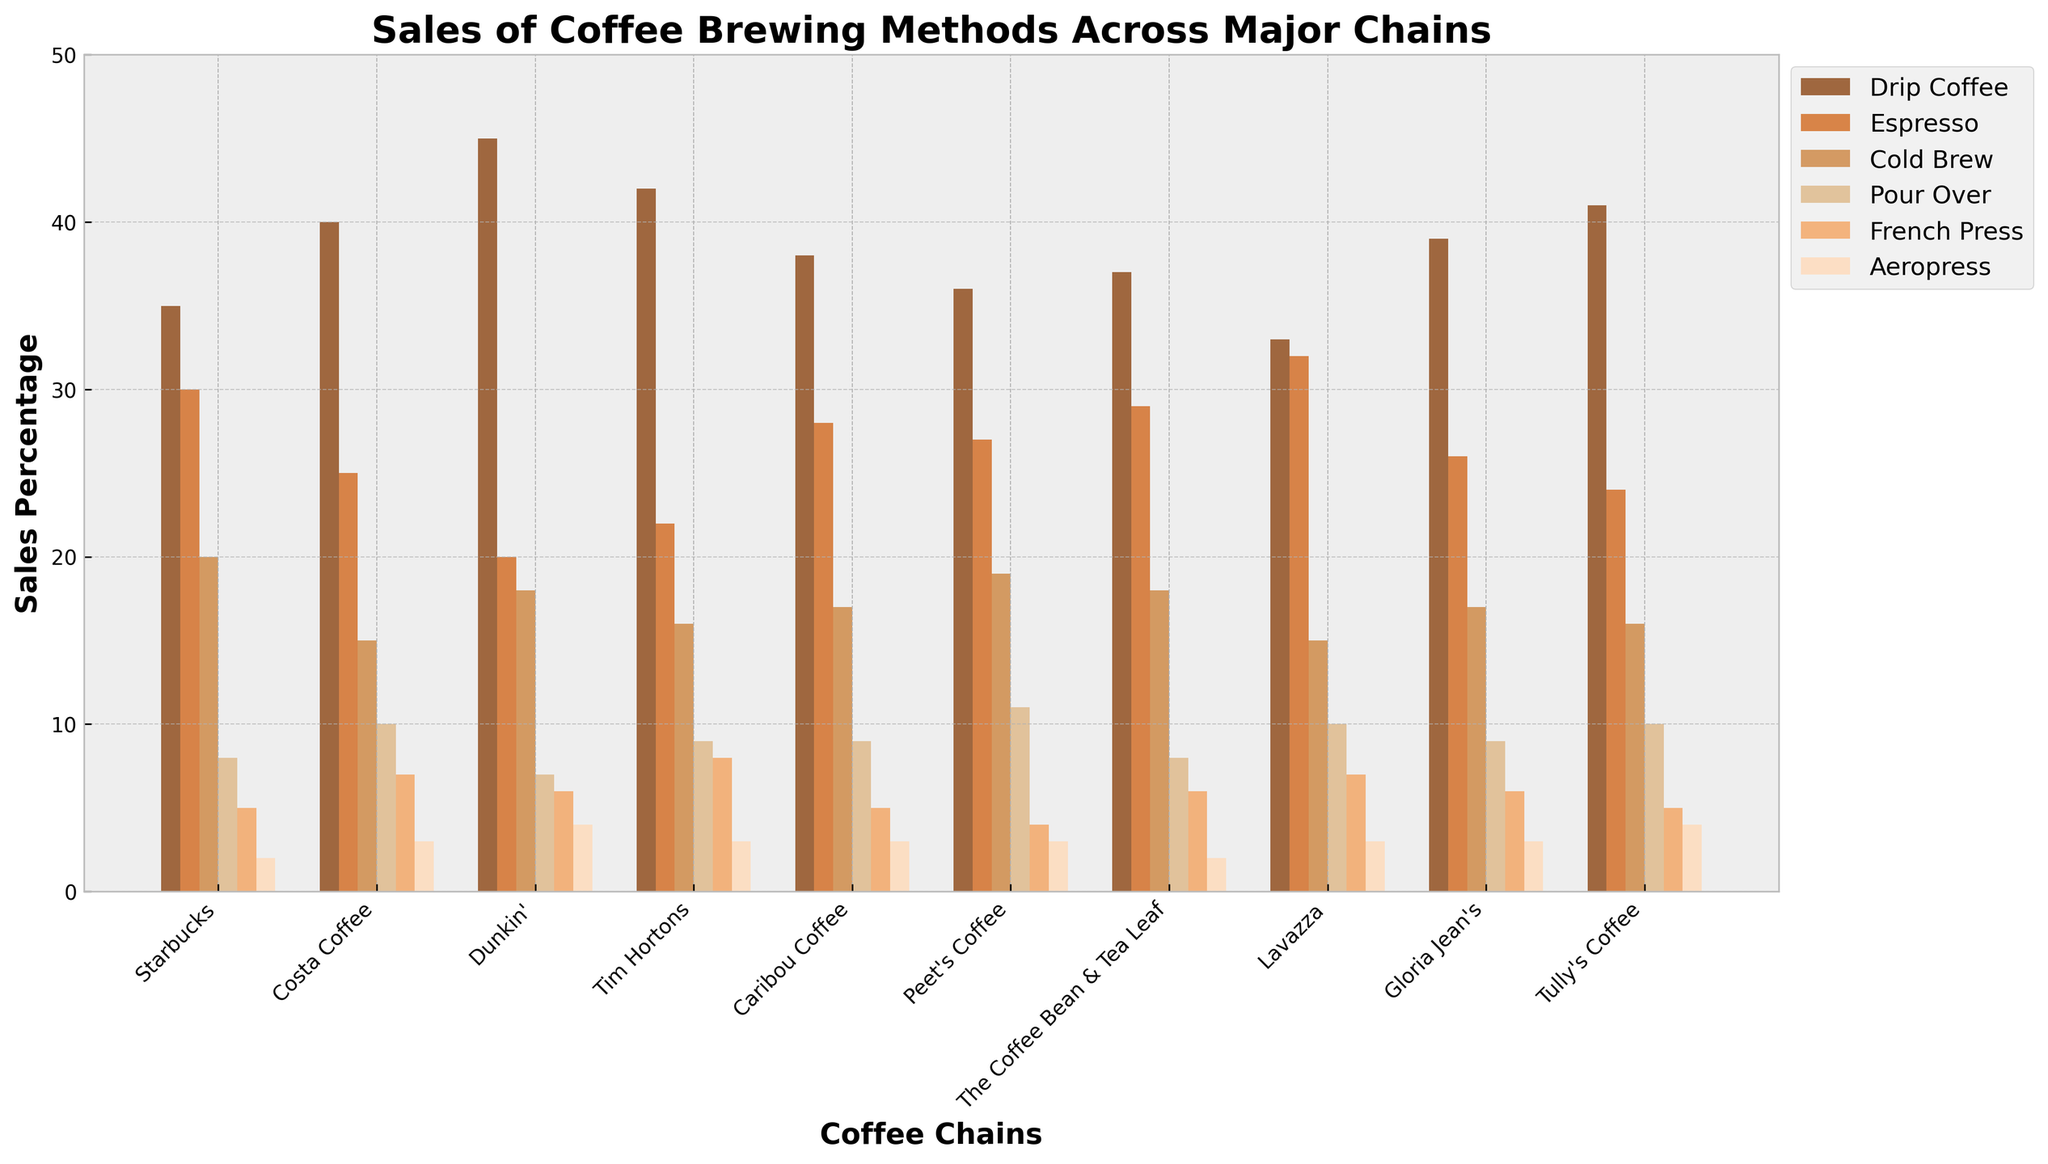Which coffee chain has the highest sales percentage of Drip Coffee? The highest bar segment for Drip Coffee (the first color) is identified visually. Dunkin' has the tallest bar for Drip Coffee.
Answer: Dunkin' Which brewing method has the lowest overall sales percentage? To determine this, compare the height of each method's bars across all coffee chains. Aeropress consistently appears as the shortest.
Answer: Aeropress Which two coffee chains have the closest sales percentages for Cold Brew? Identify the bars representing Cold Brew (the third color) and compare their heights. Starbucks and The Coffee Bean & Tea Leaf have bars of very similar height for Cold Brew.
Answer: Starbucks and The Coffee Bean & Tea Leaf What is the average sales percentage of Espresso across all coffee chains? Sum the Espresso percentages (30+25+20+22+28+27+29+32+26+24) and divide by the number of coffee chains (10). (30+25+20+22+28+27+29+32+26+24) / 10 = 26.3
Answer: 26.3 Which coffee chain has the least sales percentage for Pour Over? Identify the shortest bar for Pour Over (the fourth color) among all coffee chains. Starbucks has the shortest bar for Pour Over.
Answer: Starbucks How much higher are the sales percentages of Drip Coffee compared to French Press at Tim Hortons? Look at the heights of the bars for Drip Coffee and French Press at Tim Hortons. The Drip Coffee bar is at 42, the French Press bar is at 8. 42 - 8 = 34
Answer: 34 Which brewing method has the highest total sales percentage across all coffee chains? Sum the heights of the bars for each brewing method across all chains. Drip Coffee has the highest sum.
Answer: Drip Coffee How do the sales percentages of Pour Over compare between Costa Coffee and Tully's Coffee? Look at the bars for Pour Over (the fourth color) in both Costa Coffee and Tully's Coffee. Costa Coffee has a height of 10, and Tully's Coffee has a height of 10. They are equal.
Answer: Equal Which brewing method appears second most popular at Lavazza? Identify the second tallest bar segment at Lavazza. The second tallest bar is for Drip Coffee.
Answer: Drip Coffee For which brewing method does Starbucks have over 30% sales? Identify bars where Starbucks has a height greater than 30. Starbucks has over 30% for Drip Coffee.
Answer: Drip Coffee 